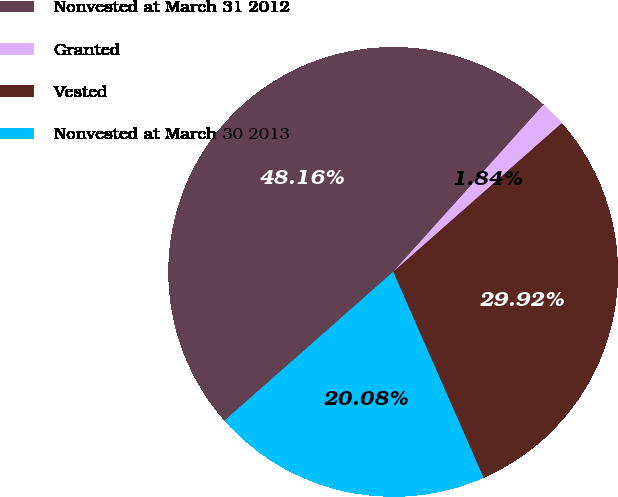Convert chart to OTSL. <chart><loc_0><loc_0><loc_500><loc_500><pie_chart><fcel>Nonvested at March 31 2012<fcel>Granted<fcel>Vested<fcel>Nonvested at March 30 2013<nl><fcel>48.16%<fcel>1.84%<fcel>29.92%<fcel>20.08%<nl></chart> 